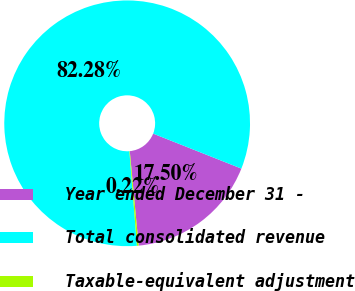Convert chart. <chart><loc_0><loc_0><loc_500><loc_500><pie_chart><fcel>Year ended December 31 -<fcel>Total consolidated revenue<fcel>Taxable-equivalent adjustment<nl><fcel>17.5%<fcel>82.28%<fcel>0.22%<nl></chart> 